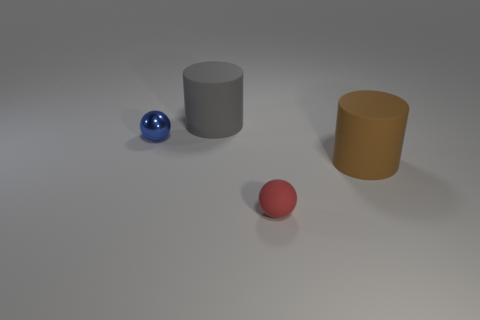Add 2 small objects. How many objects exist? 6 Add 4 red rubber objects. How many red rubber objects are left? 5 Add 1 red objects. How many red objects exist? 2 Subtract 0 yellow cubes. How many objects are left? 4 Subtract all big red rubber things. Subtract all big gray rubber cylinders. How many objects are left? 3 